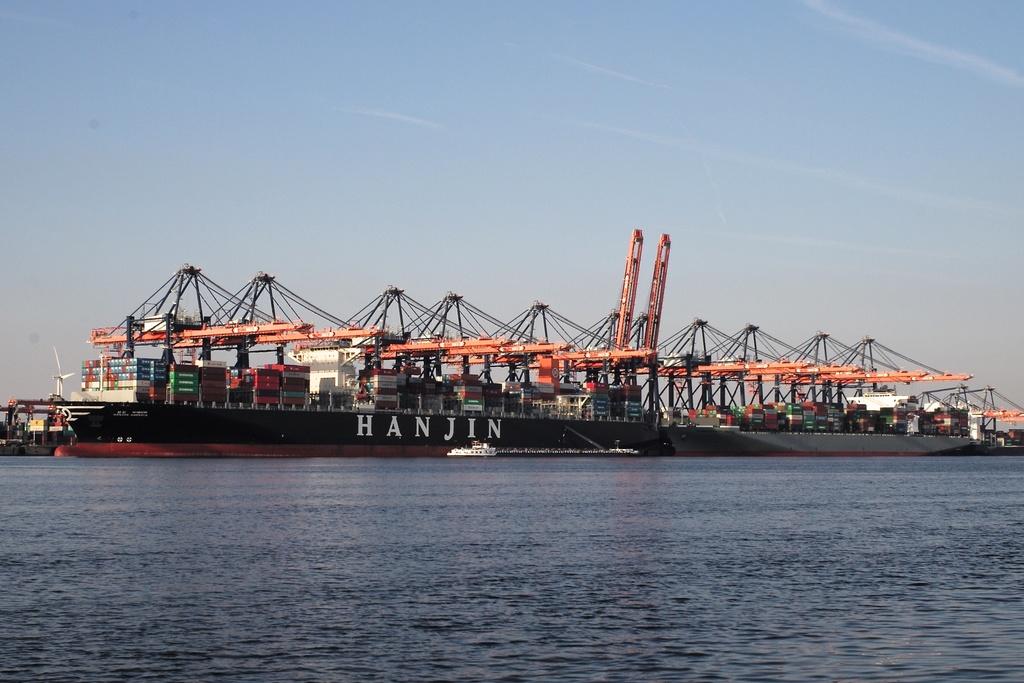What is written on this boat?
Provide a short and direct response. Hanjin. What color of letters are used?
Provide a succinct answer. White. 